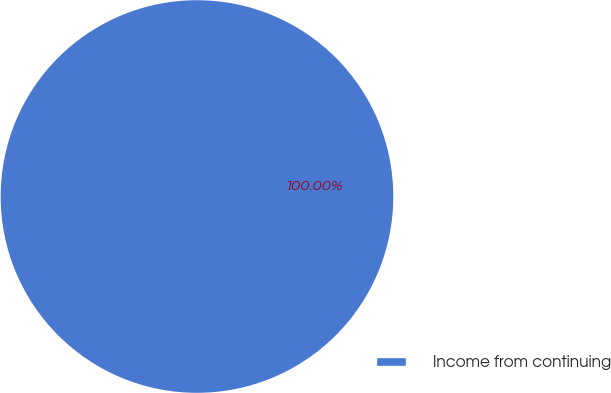Convert chart. <chart><loc_0><loc_0><loc_500><loc_500><pie_chart><fcel>Income from continuing<nl><fcel>100.0%<nl></chart> 